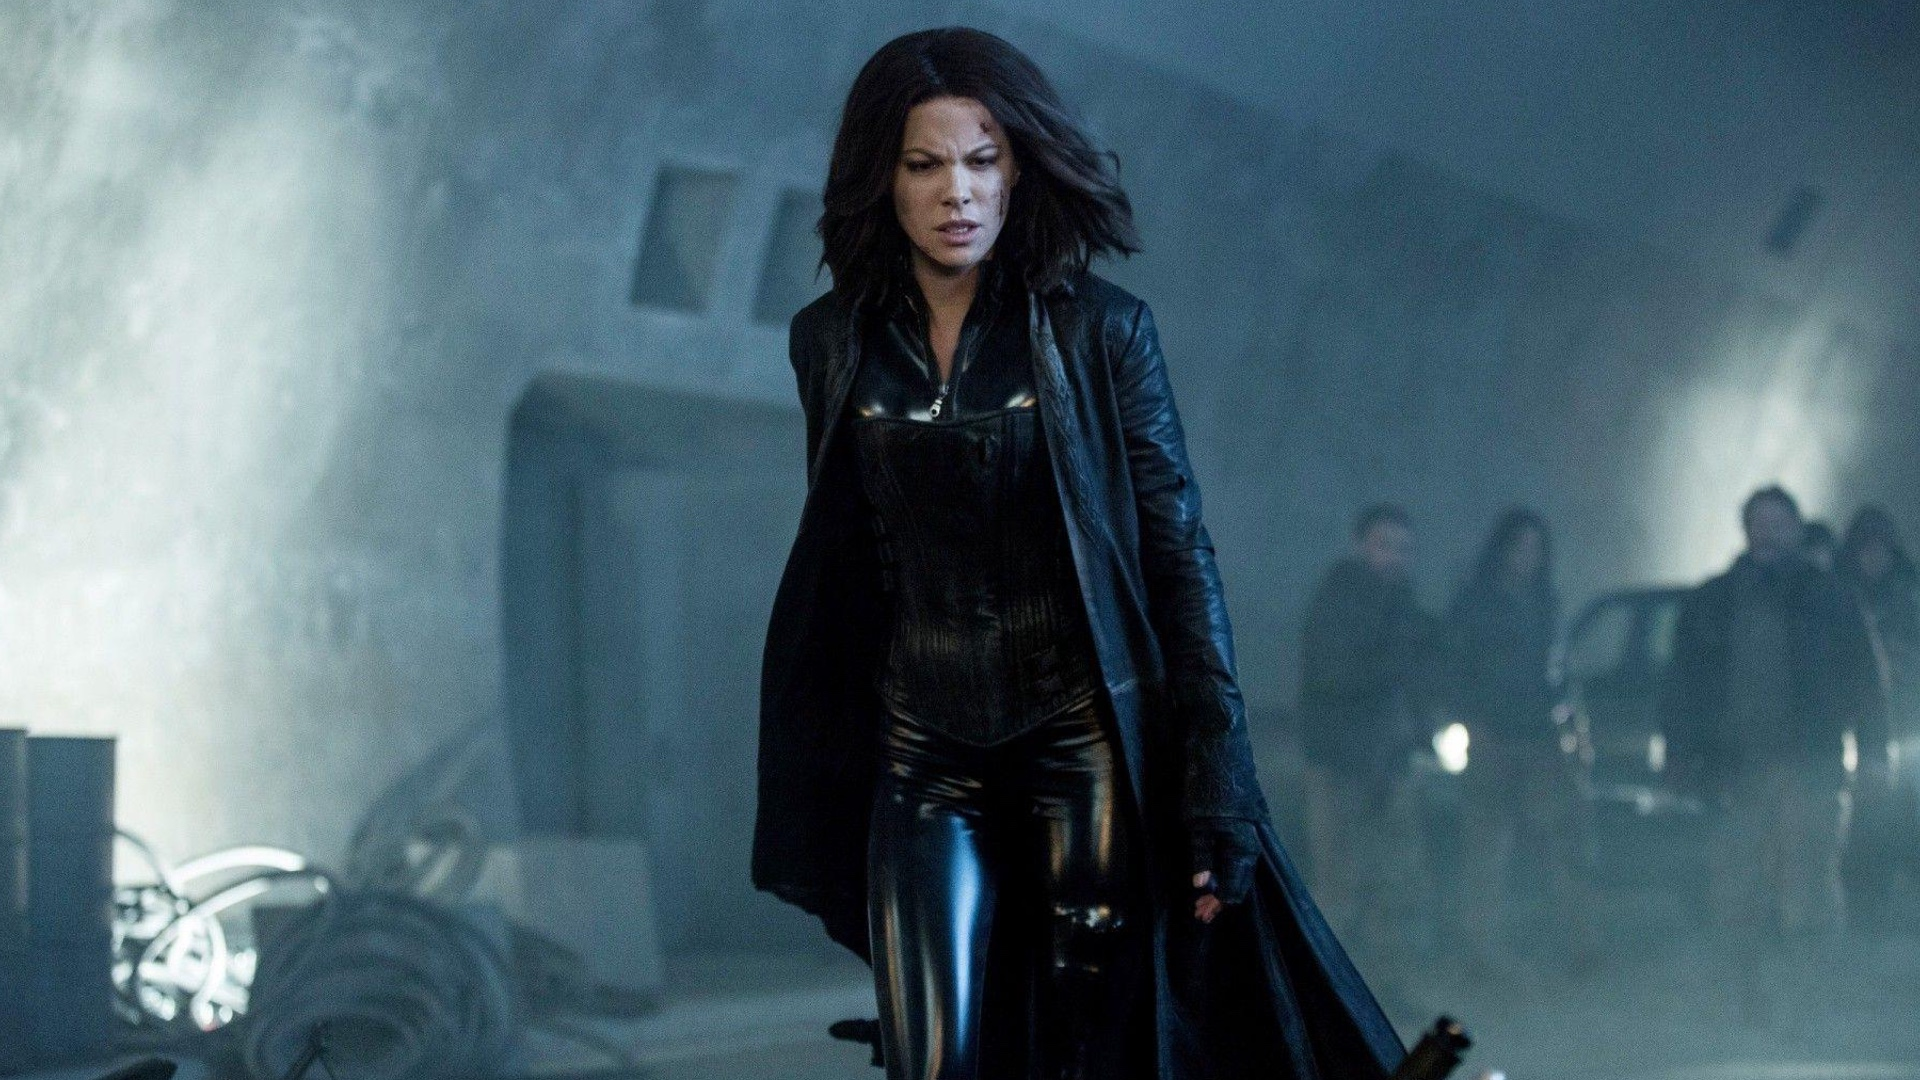What are the key elements in this picture? The image showcases a figure in a full-length black leather outfit that includes a coat and high boots, set against an industrial background with fog. The character appears focused and resolute, walking forward with intent. This style and setting evoke a gothic and dark ambiance indicative of certain cinematic themes. The muted lighting and steam or fog contribute to an atmosphere of mystery and tension. 